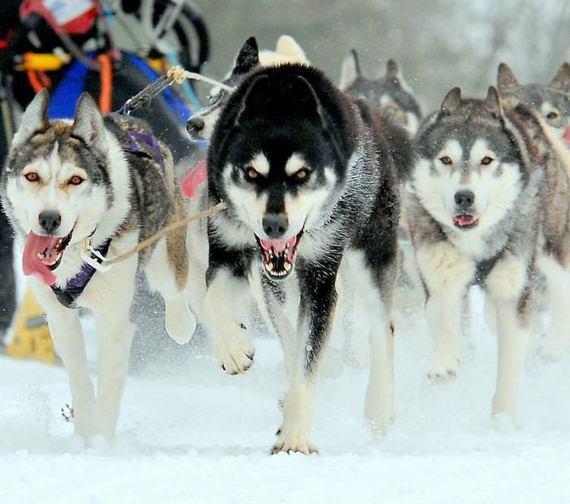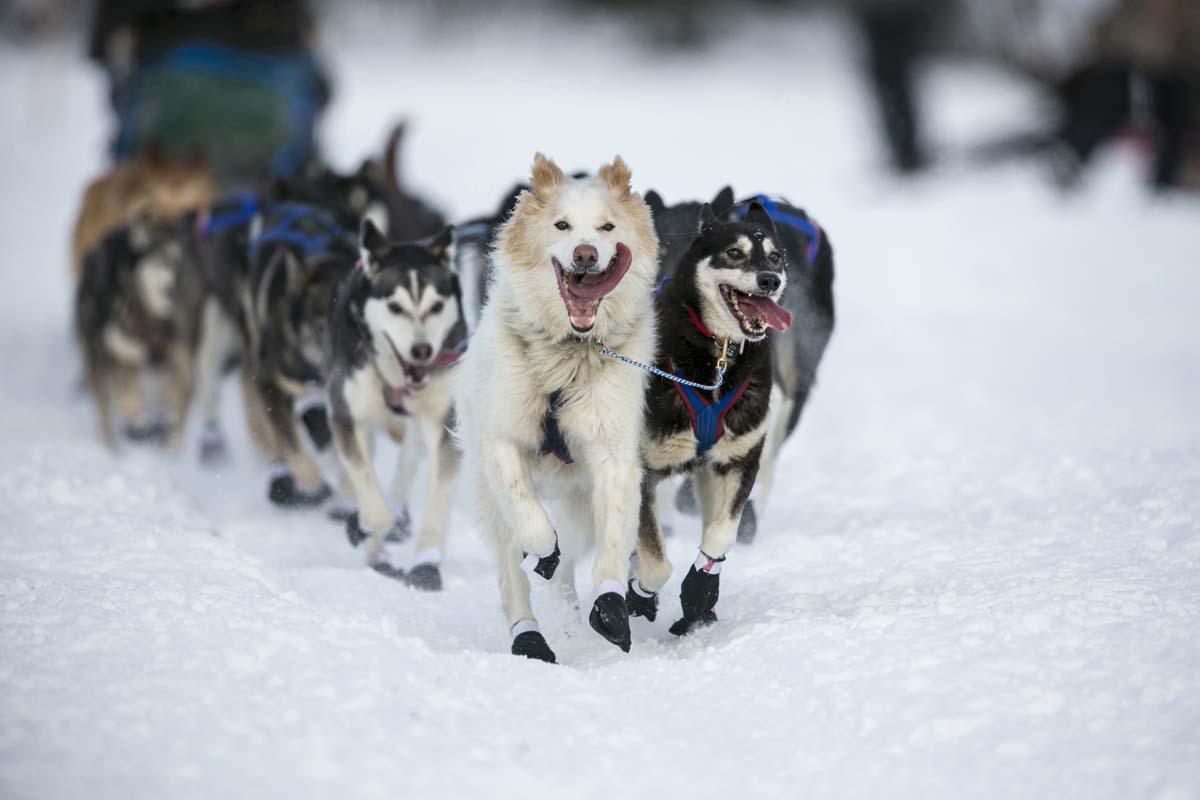The first image is the image on the left, the second image is the image on the right. Assess this claim about the two images: "The left image contains exactly one dog.". Correct or not? Answer yes or no. No. The first image is the image on the left, the second image is the image on the right. Evaluate the accuracy of this statement regarding the images: "An image shows a multicolored dog wearing a red harness that extends out of the snowy scene.". Is it true? Answer yes or no. No. 